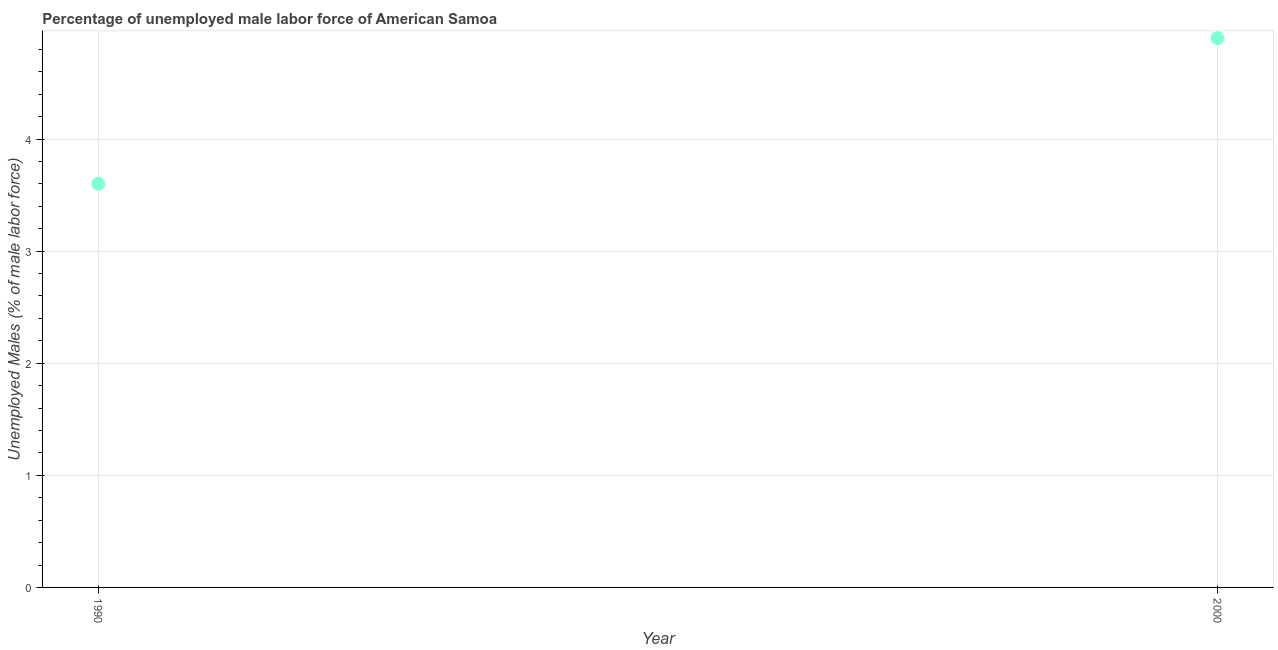What is the total unemployed male labour force in 2000?
Provide a succinct answer. 4.9. Across all years, what is the maximum total unemployed male labour force?
Your answer should be very brief. 4.9. Across all years, what is the minimum total unemployed male labour force?
Your answer should be very brief. 3.6. In which year was the total unemployed male labour force maximum?
Your answer should be very brief. 2000. What is the difference between the total unemployed male labour force in 1990 and 2000?
Offer a very short reply. -1.3. What is the average total unemployed male labour force per year?
Provide a short and direct response. 4.25. What is the median total unemployed male labour force?
Keep it short and to the point. 4.25. In how many years, is the total unemployed male labour force greater than 1.2 %?
Give a very brief answer. 2. Do a majority of the years between 1990 and 2000 (inclusive) have total unemployed male labour force greater than 3.4 %?
Offer a terse response. Yes. What is the ratio of the total unemployed male labour force in 1990 to that in 2000?
Your answer should be very brief. 0.73. How many years are there in the graph?
Your answer should be compact. 2. What is the difference between two consecutive major ticks on the Y-axis?
Keep it short and to the point. 1. Are the values on the major ticks of Y-axis written in scientific E-notation?
Provide a short and direct response. No. What is the title of the graph?
Provide a short and direct response. Percentage of unemployed male labor force of American Samoa. What is the label or title of the Y-axis?
Your answer should be compact. Unemployed Males (% of male labor force). What is the Unemployed Males (% of male labor force) in 1990?
Make the answer very short. 3.6. What is the Unemployed Males (% of male labor force) in 2000?
Provide a succinct answer. 4.9. What is the difference between the Unemployed Males (% of male labor force) in 1990 and 2000?
Provide a succinct answer. -1.3. What is the ratio of the Unemployed Males (% of male labor force) in 1990 to that in 2000?
Provide a short and direct response. 0.73. 